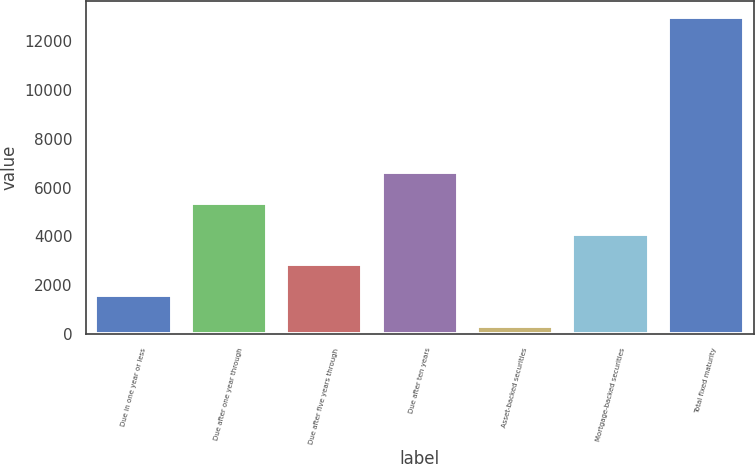<chart> <loc_0><loc_0><loc_500><loc_500><bar_chart><fcel>Due in one year or less<fcel>Due after one year through<fcel>Due after five years through<fcel>Due after ten years<fcel>Asset-backed securities<fcel>Mortgage-backed securities<fcel>Total fixed maturity<nl><fcel>1582.92<fcel>5390.58<fcel>2852.14<fcel>6659.8<fcel>313.7<fcel>4121.36<fcel>13005.9<nl></chart> 